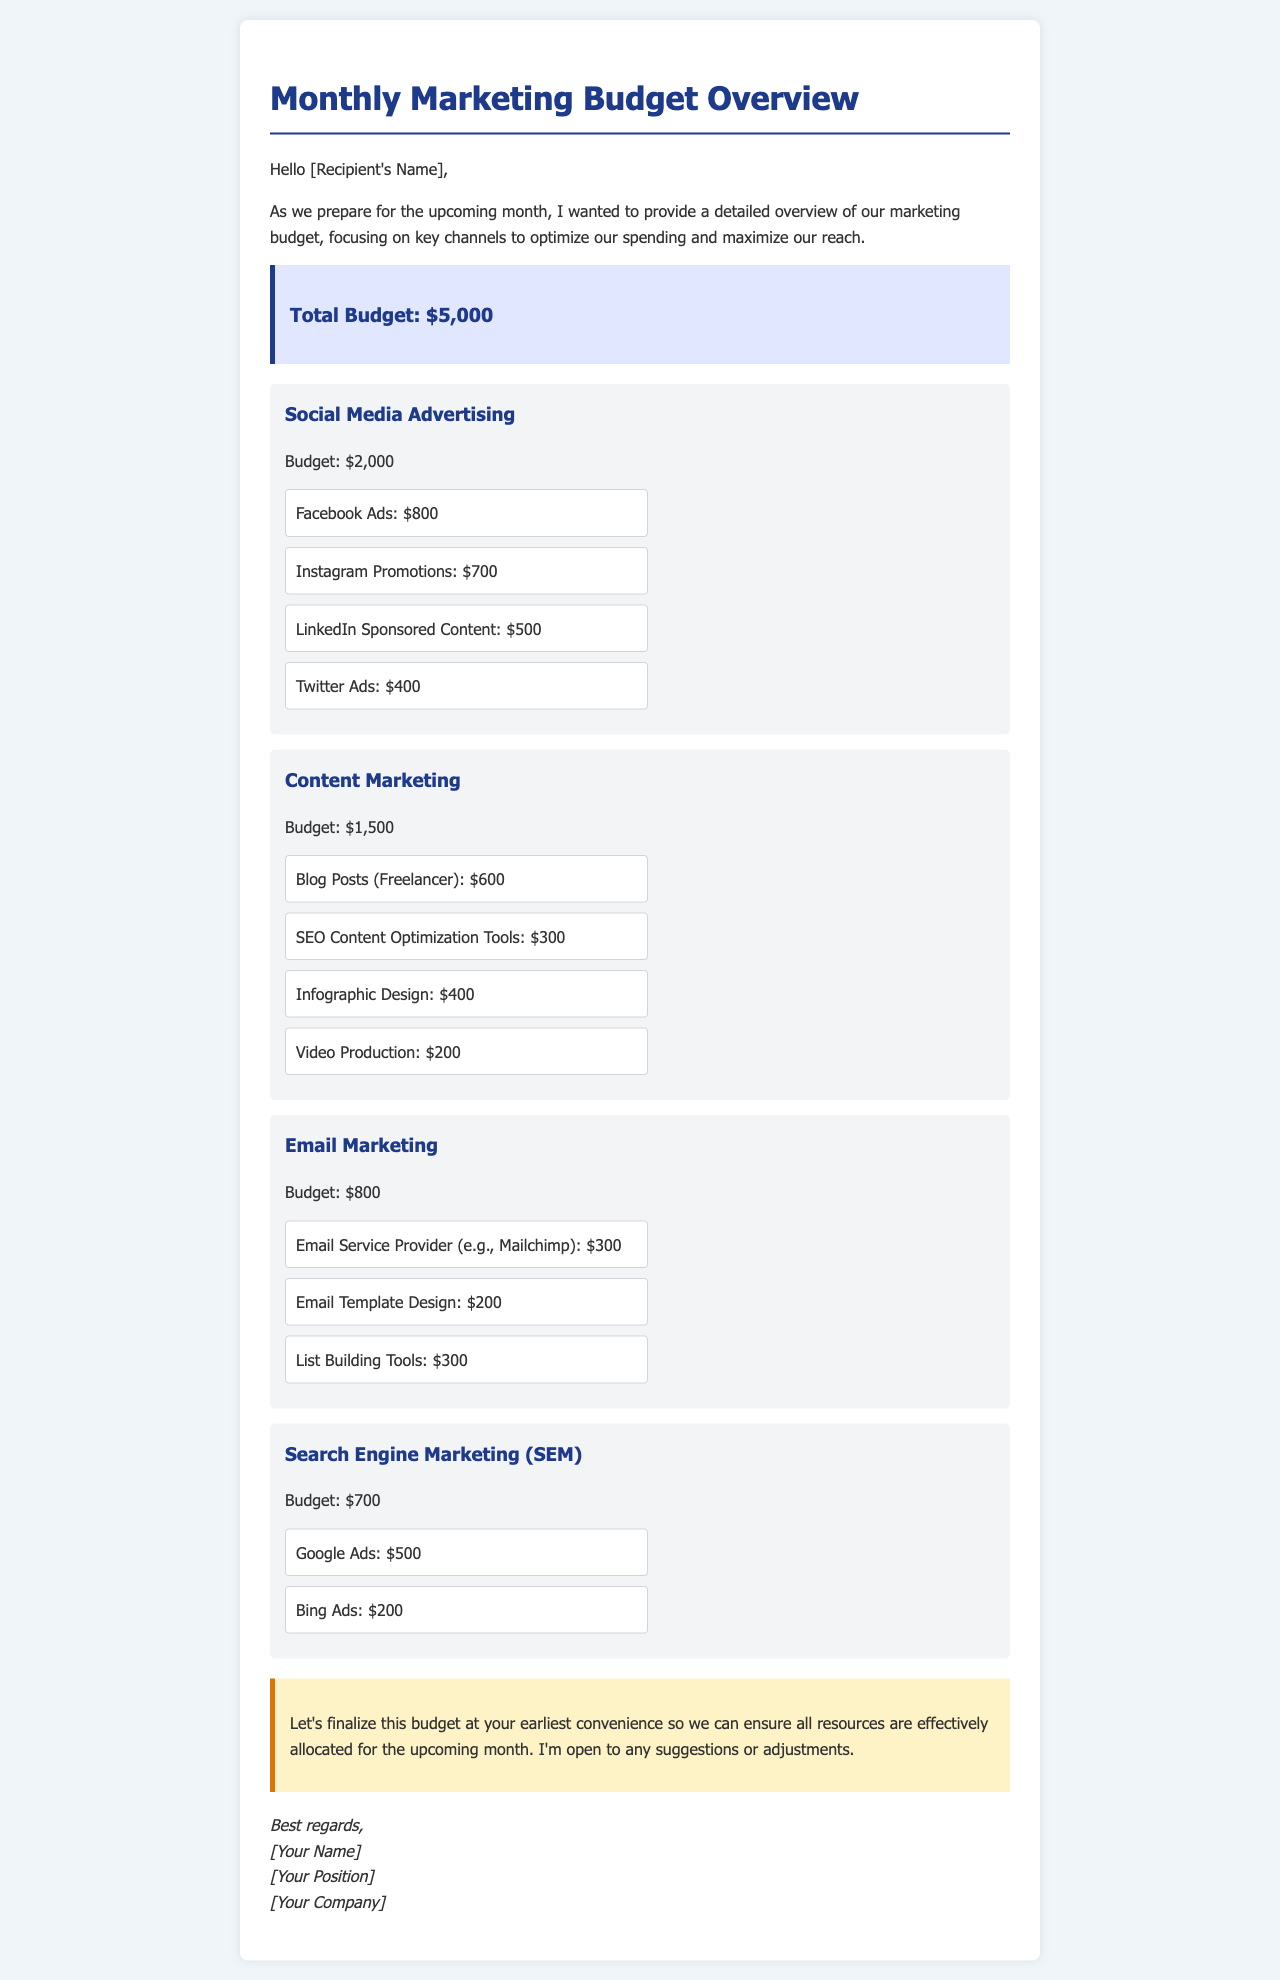what is the total budget allocated for marketing? The total budget is explicitly stated in the document, which is $5,000.
Answer: $5,000 how much is allocated for Social Media Advertising? The budget for Social Media Advertising is explicitly mentioned in the document, which is $2,000.
Answer: $2,000 what is the cost for Google Ads? The cost for Google Ads is provided under the SEM section in the document, which is $500.
Answer: $500 how much will be spent on Blog Posts (Freelancer)? The cost for Blog Posts is directly mentioned in the Content Marketing section, which is $600.
Answer: $600 which channel has the highest budget? The channel with the highest budget can be determined by comparing the budgets listed; Social Media Advertising has $2,000, which is the highest.
Answer: Social Media Advertising what is the total budget for Content Marketing? The total budget for Content Marketing is listed in the document as $1,500.
Answer: $1,500 how much is allocated for Email Service Provider? The amount specified for the Email Service Provider is $300, found in the Email Marketing section.
Answer: $300 which channel has a budget of $700? The channel with a budget of $700 is explicitly stated in the document as Search Engine Marketing (SEM).
Answer: Search Engine Marketing (SEM) what is the lowest budget assigned to a single channel? The lowest budget can be identified by looking at the individual channel budgets; Email Marketing has the lowest allocation of $800.
Answer: Email Marketing 